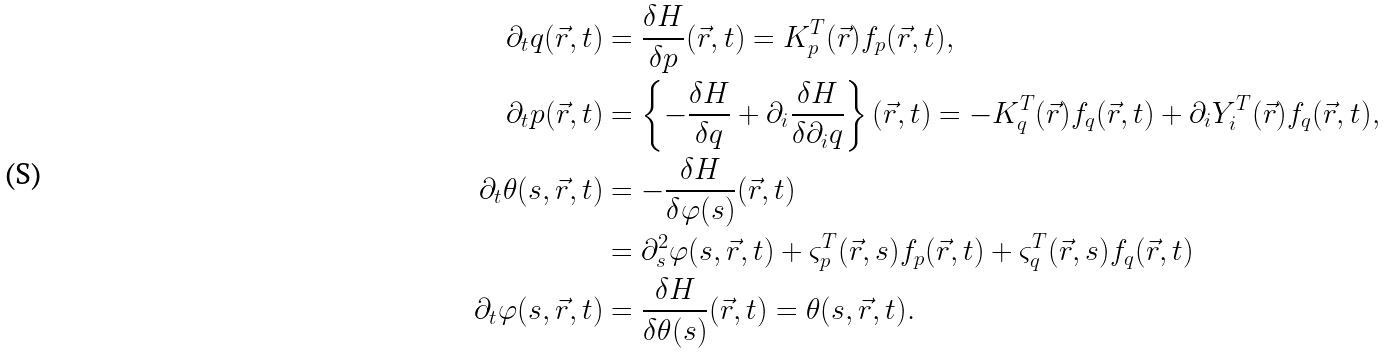Convert formula to latex. <formula><loc_0><loc_0><loc_500><loc_500>\partial _ { t } q ( \vec { r } , t ) & = \frac { \delta H } { \delta p } ( \vec { r } , t ) = K _ { p } ^ { T } ( \vec { r } ) f _ { p } ( \vec { r } , t ) , \\ \partial _ { t } p ( \vec { r } , t ) & = \left \{ - \frac { \delta H } { \delta q } + \partial _ { i } \frac { \delta H } { \delta \partial _ { i } q } \right \} ( \vec { r } , t ) = - K _ { q } ^ { T } ( \vec { r } ) f _ { q } ( \vec { r } , t ) + \partial _ { i } Y _ { i } ^ { T } ( \vec { r } ) f _ { q } ( \vec { r } , t ) , \\ \partial _ { t } \theta ( s , \vec { r } , t ) & = - \frac { \delta H } { \delta \varphi ( s ) } ( \vec { r } , t ) \\ & = \partial _ { s } ^ { 2 } \varphi ( s , \vec { r } , t ) + \varsigma _ { p } ^ { T } ( \vec { r } , s ) f _ { p } ( \vec { r } , t ) + \varsigma _ { q } ^ { T } ( \vec { r } , s ) f _ { q } ( \vec { r } , t ) \\ \partial _ { t } \varphi ( s , \vec { r } , t ) & = \frac { \delta H } { \delta \theta ( s ) } ( \vec { r } , t ) = \theta ( s , \vec { r } , t ) .</formula> 